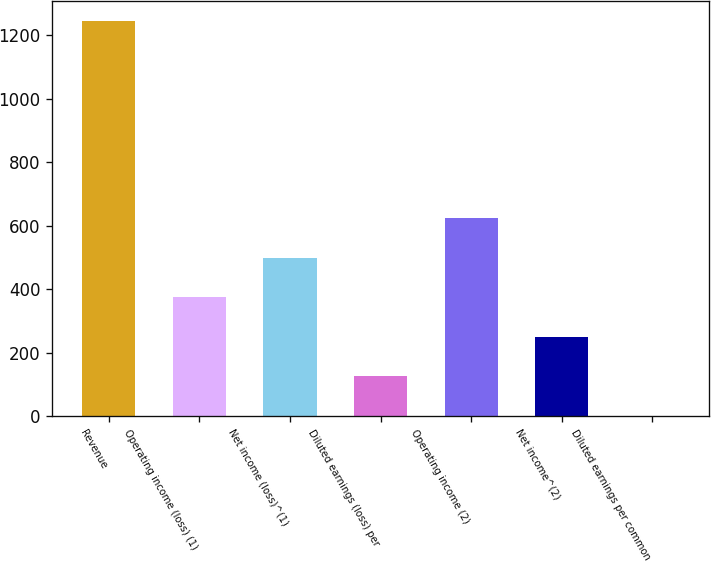<chart> <loc_0><loc_0><loc_500><loc_500><bar_chart><fcel>Revenue<fcel>Operating income (loss) (1)<fcel>Net income (loss)^(1)<fcel>Diluted earnings (loss) per<fcel>Operating income (2)<fcel>Net income^(2)<fcel>Diluted earnings per common<nl><fcel>1244.4<fcel>373.64<fcel>498.04<fcel>124.84<fcel>622.44<fcel>249.24<fcel>0.44<nl></chart> 